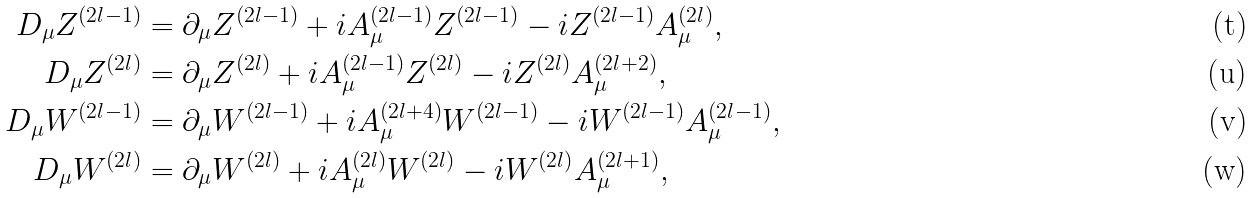Convert formula to latex. <formula><loc_0><loc_0><loc_500><loc_500>D _ { \mu } Z ^ { ( 2 l - 1 ) } & = \partial _ { \mu } Z ^ { ( 2 l - 1 ) } + i A ^ { ( 2 l - 1 ) } _ { \mu } Z ^ { ( 2 l - 1 ) } - i Z ^ { ( 2 l - 1 ) } A ^ { ( 2 l ) } _ { \mu } , \\ D _ { \mu } Z ^ { ( 2 l ) } & = \partial _ { \mu } Z ^ { ( 2 l ) } + i A ^ { ( 2 l - 1 ) } _ { \mu } Z ^ { ( 2 l ) } - i Z ^ { ( 2 l ) } A ^ { ( 2 l + 2 ) } _ { \mu } , \\ D _ { \mu } W ^ { ( 2 l - 1 ) } & = \partial _ { \mu } W ^ { ( 2 l - 1 ) } + i A ^ { ( 2 l + 4 ) } _ { \mu } W ^ { ( 2 l - 1 ) } - i W ^ { ( 2 l - 1 ) } A ^ { ( 2 l - 1 ) } _ { \mu } , \\ D _ { \mu } W ^ { ( 2 l ) } & = \partial _ { \mu } W ^ { ( 2 l ) } + i A ^ { ( 2 l ) } _ { \mu } W ^ { ( 2 l ) } - i W ^ { ( 2 l ) } A ^ { ( 2 l + 1 ) } _ { \mu } ,</formula> 